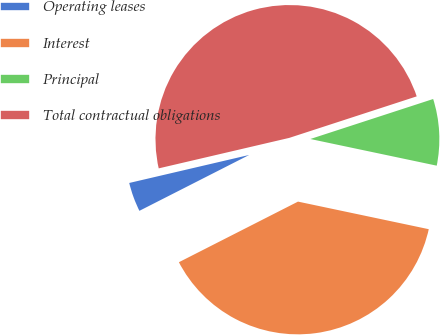Convert chart to OTSL. <chart><loc_0><loc_0><loc_500><loc_500><pie_chart><fcel>Operating leases<fcel>Interest<fcel>Principal<fcel>Total contractual obligations<nl><fcel>3.84%<fcel>39.2%<fcel>8.32%<fcel>48.64%<nl></chart> 